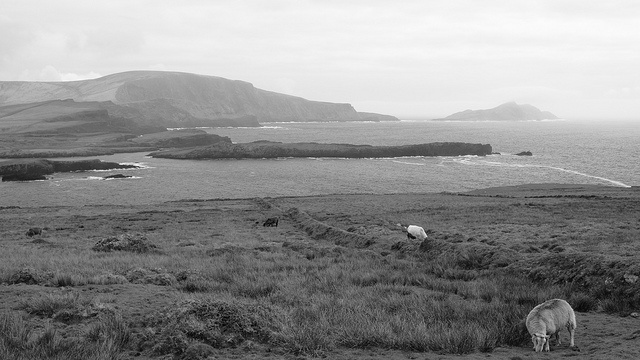Describe the objects in this image and their specific colors. I can see sheep in lightgray, gray, and black tones, sheep in lightgray, darkgray, gray, and black tones, and sheep in gray, black, and lightgray tones in this image. 